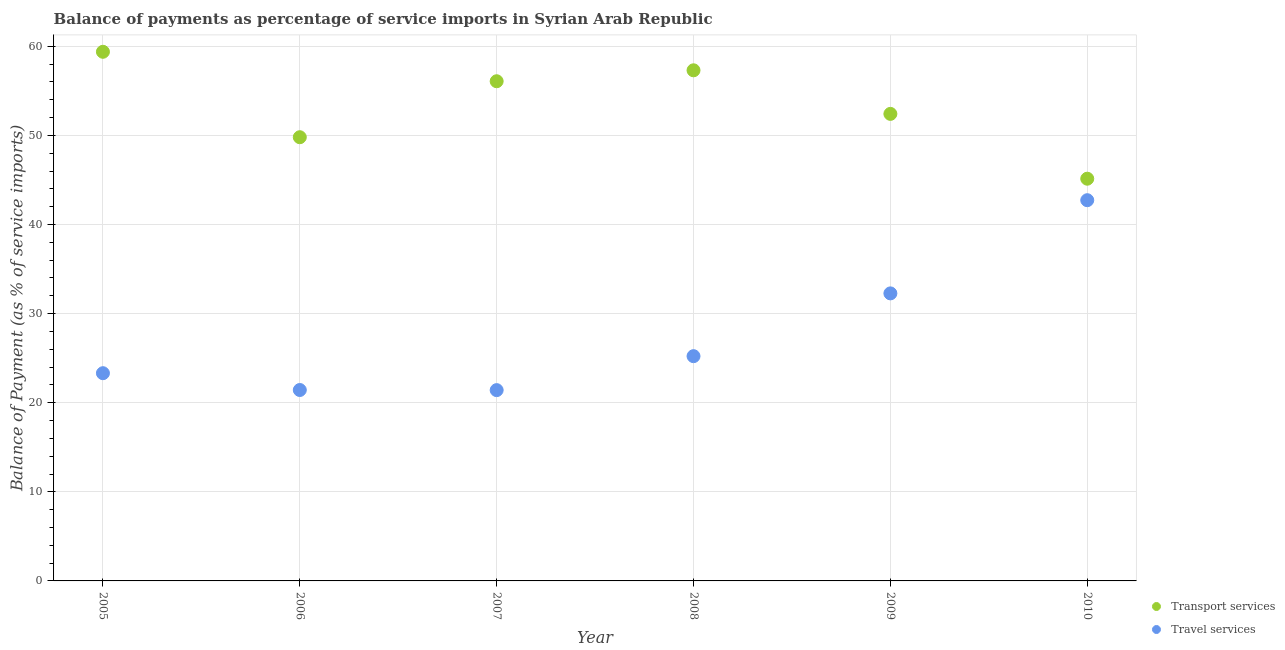Is the number of dotlines equal to the number of legend labels?
Offer a terse response. Yes. What is the balance of payments of travel services in 2010?
Make the answer very short. 42.73. Across all years, what is the maximum balance of payments of transport services?
Your answer should be compact. 59.39. Across all years, what is the minimum balance of payments of travel services?
Your response must be concise. 21.41. In which year was the balance of payments of travel services minimum?
Ensure brevity in your answer.  2007. What is the total balance of payments of transport services in the graph?
Make the answer very short. 320.15. What is the difference between the balance of payments of travel services in 2007 and that in 2008?
Your answer should be very brief. -3.81. What is the difference between the balance of payments of travel services in 2006 and the balance of payments of transport services in 2008?
Your response must be concise. -35.88. What is the average balance of payments of transport services per year?
Your answer should be compact. 53.36. In the year 2005, what is the difference between the balance of payments of transport services and balance of payments of travel services?
Your answer should be very brief. 36.07. What is the ratio of the balance of payments of transport services in 2006 to that in 2009?
Your response must be concise. 0.95. Is the balance of payments of travel services in 2007 less than that in 2009?
Your response must be concise. Yes. Is the difference between the balance of payments of transport services in 2008 and 2010 greater than the difference between the balance of payments of travel services in 2008 and 2010?
Keep it short and to the point. Yes. What is the difference between the highest and the second highest balance of payments of travel services?
Ensure brevity in your answer.  10.46. What is the difference between the highest and the lowest balance of payments of transport services?
Your answer should be compact. 14.24. Is the sum of the balance of payments of transport services in 2007 and 2010 greater than the maximum balance of payments of travel services across all years?
Give a very brief answer. Yes. Is the balance of payments of transport services strictly greater than the balance of payments of travel services over the years?
Make the answer very short. Yes. How many years are there in the graph?
Your answer should be compact. 6. What is the difference between two consecutive major ticks on the Y-axis?
Make the answer very short. 10. Are the values on the major ticks of Y-axis written in scientific E-notation?
Provide a short and direct response. No. Does the graph contain any zero values?
Your answer should be very brief. No. What is the title of the graph?
Ensure brevity in your answer.  Balance of payments as percentage of service imports in Syrian Arab Republic. What is the label or title of the X-axis?
Keep it short and to the point. Year. What is the label or title of the Y-axis?
Your answer should be compact. Balance of Payment (as % of service imports). What is the Balance of Payment (as % of service imports) in Transport services in 2005?
Your response must be concise. 59.39. What is the Balance of Payment (as % of service imports) of Travel services in 2005?
Your response must be concise. 23.31. What is the Balance of Payment (as % of service imports) in Transport services in 2006?
Your answer should be compact. 49.8. What is the Balance of Payment (as % of service imports) of Travel services in 2006?
Offer a very short reply. 21.43. What is the Balance of Payment (as % of service imports) of Transport services in 2007?
Your response must be concise. 56.08. What is the Balance of Payment (as % of service imports) of Travel services in 2007?
Your answer should be compact. 21.41. What is the Balance of Payment (as % of service imports) of Transport services in 2008?
Offer a terse response. 57.31. What is the Balance of Payment (as % of service imports) of Travel services in 2008?
Provide a succinct answer. 25.23. What is the Balance of Payment (as % of service imports) of Transport services in 2009?
Your response must be concise. 52.42. What is the Balance of Payment (as % of service imports) in Travel services in 2009?
Your answer should be very brief. 32.27. What is the Balance of Payment (as % of service imports) of Transport services in 2010?
Provide a short and direct response. 45.14. What is the Balance of Payment (as % of service imports) in Travel services in 2010?
Make the answer very short. 42.73. Across all years, what is the maximum Balance of Payment (as % of service imports) in Transport services?
Your response must be concise. 59.39. Across all years, what is the maximum Balance of Payment (as % of service imports) in Travel services?
Keep it short and to the point. 42.73. Across all years, what is the minimum Balance of Payment (as % of service imports) of Transport services?
Your answer should be very brief. 45.14. Across all years, what is the minimum Balance of Payment (as % of service imports) of Travel services?
Give a very brief answer. 21.41. What is the total Balance of Payment (as % of service imports) of Transport services in the graph?
Ensure brevity in your answer.  320.15. What is the total Balance of Payment (as % of service imports) of Travel services in the graph?
Ensure brevity in your answer.  166.39. What is the difference between the Balance of Payment (as % of service imports) of Transport services in 2005 and that in 2006?
Provide a succinct answer. 9.59. What is the difference between the Balance of Payment (as % of service imports) of Travel services in 2005 and that in 2006?
Make the answer very short. 1.89. What is the difference between the Balance of Payment (as % of service imports) of Transport services in 2005 and that in 2007?
Provide a short and direct response. 3.31. What is the difference between the Balance of Payment (as % of service imports) in Travel services in 2005 and that in 2007?
Offer a terse response. 1.9. What is the difference between the Balance of Payment (as % of service imports) in Transport services in 2005 and that in 2008?
Your response must be concise. 2.08. What is the difference between the Balance of Payment (as % of service imports) in Travel services in 2005 and that in 2008?
Offer a terse response. -1.91. What is the difference between the Balance of Payment (as % of service imports) of Transport services in 2005 and that in 2009?
Make the answer very short. 6.97. What is the difference between the Balance of Payment (as % of service imports) of Travel services in 2005 and that in 2009?
Provide a succinct answer. -8.96. What is the difference between the Balance of Payment (as % of service imports) in Transport services in 2005 and that in 2010?
Provide a succinct answer. 14.24. What is the difference between the Balance of Payment (as % of service imports) of Travel services in 2005 and that in 2010?
Offer a terse response. -19.42. What is the difference between the Balance of Payment (as % of service imports) of Transport services in 2006 and that in 2007?
Offer a terse response. -6.28. What is the difference between the Balance of Payment (as % of service imports) of Travel services in 2006 and that in 2007?
Keep it short and to the point. 0.01. What is the difference between the Balance of Payment (as % of service imports) in Transport services in 2006 and that in 2008?
Provide a succinct answer. -7.51. What is the difference between the Balance of Payment (as % of service imports) of Travel services in 2006 and that in 2008?
Offer a very short reply. -3.8. What is the difference between the Balance of Payment (as % of service imports) in Transport services in 2006 and that in 2009?
Your answer should be very brief. -2.62. What is the difference between the Balance of Payment (as % of service imports) of Travel services in 2006 and that in 2009?
Provide a short and direct response. -10.84. What is the difference between the Balance of Payment (as % of service imports) of Transport services in 2006 and that in 2010?
Your response must be concise. 4.66. What is the difference between the Balance of Payment (as % of service imports) of Travel services in 2006 and that in 2010?
Ensure brevity in your answer.  -21.3. What is the difference between the Balance of Payment (as % of service imports) in Transport services in 2007 and that in 2008?
Provide a succinct answer. -1.23. What is the difference between the Balance of Payment (as % of service imports) of Travel services in 2007 and that in 2008?
Provide a succinct answer. -3.81. What is the difference between the Balance of Payment (as % of service imports) of Transport services in 2007 and that in 2009?
Your response must be concise. 3.66. What is the difference between the Balance of Payment (as % of service imports) of Travel services in 2007 and that in 2009?
Provide a succinct answer. -10.86. What is the difference between the Balance of Payment (as % of service imports) in Transport services in 2007 and that in 2010?
Give a very brief answer. 10.94. What is the difference between the Balance of Payment (as % of service imports) of Travel services in 2007 and that in 2010?
Ensure brevity in your answer.  -21.32. What is the difference between the Balance of Payment (as % of service imports) in Transport services in 2008 and that in 2009?
Provide a succinct answer. 4.89. What is the difference between the Balance of Payment (as % of service imports) of Travel services in 2008 and that in 2009?
Make the answer very short. -7.05. What is the difference between the Balance of Payment (as % of service imports) of Transport services in 2008 and that in 2010?
Make the answer very short. 12.17. What is the difference between the Balance of Payment (as % of service imports) in Travel services in 2008 and that in 2010?
Provide a short and direct response. -17.51. What is the difference between the Balance of Payment (as % of service imports) of Transport services in 2009 and that in 2010?
Your response must be concise. 7.28. What is the difference between the Balance of Payment (as % of service imports) of Travel services in 2009 and that in 2010?
Keep it short and to the point. -10.46. What is the difference between the Balance of Payment (as % of service imports) of Transport services in 2005 and the Balance of Payment (as % of service imports) of Travel services in 2006?
Your answer should be very brief. 37.96. What is the difference between the Balance of Payment (as % of service imports) in Transport services in 2005 and the Balance of Payment (as % of service imports) in Travel services in 2007?
Ensure brevity in your answer.  37.97. What is the difference between the Balance of Payment (as % of service imports) in Transport services in 2005 and the Balance of Payment (as % of service imports) in Travel services in 2008?
Offer a terse response. 34.16. What is the difference between the Balance of Payment (as % of service imports) in Transport services in 2005 and the Balance of Payment (as % of service imports) in Travel services in 2009?
Your answer should be compact. 27.12. What is the difference between the Balance of Payment (as % of service imports) of Transport services in 2005 and the Balance of Payment (as % of service imports) of Travel services in 2010?
Your answer should be compact. 16.66. What is the difference between the Balance of Payment (as % of service imports) of Transport services in 2006 and the Balance of Payment (as % of service imports) of Travel services in 2007?
Ensure brevity in your answer.  28.39. What is the difference between the Balance of Payment (as % of service imports) of Transport services in 2006 and the Balance of Payment (as % of service imports) of Travel services in 2008?
Ensure brevity in your answer.  24.57. What is the difference between the Balance of Payment (as % of service imports) in Transport services in 2006 and the Balance of Payment (as % of service imports) in Travel services in 2009?
Keep it short and to the point. 17.53. What is the difference between the Balance of Payment (as % of service imports) in Transport services in 2006 and the Balance of Payment (as % of service imports) in Travel services in 2010?
Provide a short and direct response. 7.07. What is the difference between the Balance of Payment (as % of service imports) in Transport services in 2007 and the Balance of Payment (as % of service imports) in Travel services in 2008?
Your response must be concise. 30.86. What is the difference between the Balance of Payment (as % of service imports) in Transport services in 2007 and the Balance of Payment (as % of service imports) in Travel services in 2009?
Ensure brevity in your answer.  23.81. What is the difference between the Balance of Payment (as % of service imports) in Transport services in 2007 and the Balance of Payment (as % of service imports) in Travel services in 2010?
Give a very brief answer. 13.35. What is the difference between the Balance of Payment (as % of service imports) of Transport services in 2008 and the Balance of Payment (as % of service imports) of Travel services in 2009?
Make the answer very short. 25.04. What is the difference between the Balance of Payment (as % of service imports) of Transport services in 2008 and the Balance of Payment (as % of service imports) of Travel services in 2010?
Your answer should be very brief. 14.58. What is the difference between the Balance of Payment (as % of service imports) of Transport services in 2009 and the Balance of Payment (as % of service imports) of Travel services in 2010?
Provide a short and direct response. 9.69. What is the average Balance of Payment (as % of service imports) in Transport services per year?
Provide a short and direct response. 53.36. What is the average Balance of Payment (as % of service imports) in Travel services per year?
Provide a succinct answer. 27.73. In the year 2005, what is the difference between the Balance of Payment (as % of service imports) in Transport services and Balance of Payment (as % of service imports) in Travel services?
Provide a short and direct response. 36.07. In the year 2006, what is the difference between the Balance of Payment (as % of service imports) of Transport services and Balance of Payment (as % of service imports) of Travel services?
Offer a very short reply. 28.37. In the year 2007, what is the difference between the Balance of Payment (as % of service imports) in Transport services and Balance of Payment (as % of service imports) in Travel services?
Keep it short and to the point. 34.67. In the year 2008, what is the difference between the Balance of Payment (as % of service imports) in Transport services and Balance of Payment (as % of service imports) in Travel services?
Offer a terse response. 32.09. In the year 2009, what is the difference between the Balance of Payment (as % of service imports) in Transport services and Balance of Payment (as % of service imports) in Travel services?
Your answer should be very brief. 20.15. In the year 2010, what is the difference between the Balance of Payment (as % of service imports) in Transport services and Balance of Payment (as % of service imports) in Travel services?
Provide a succinct answer. 2.41. What is the ratio of the Balance of Payment (as % of service imports) of Transport services in 2005 to that in 2006?
Offer a very short reply. 1.19. What is the ratio of the Balance of Payment (as % of service imports) of Travel services in 2005 to that in 2006?
Offer a very short reply. 1.09. What is the ratio of the Balance of Payment (as % of service imports) in Transport services in 2005 to that in 2007?
Provide a short and direct response. 1.06. What is the ratio of the Balance of Payment (as % of service imports) in Travel services in 2005 to that in 2007?
Provide a short and direct response. 1.09. What is the ratio of the Balance of Payment (as % of service imports) in Transport services in 2005 to that in 2008?
Your answer should be compact. 1.04. What is the ratio of the Balance of Payment (as % of service imports) of Travel services in 2005 to that in 2008?
Make the answer very short. 0.92. What is the ratio of the Balance of Payment (as % of service imports) in Transport services in 2005 to that in 2009?
Offer a very short reply. 1.13. What is the ratio of the Balance of Payment (as % of service imports) in Travel services in 2005 to that in 2009?
Your response must be concise. 0.72. What is the ratio of the Balance of Payment (as % of service imports) in Transport services in 2005 to that in 2010?
Keep it short and to the point. 1.32. What is the ratio of the Balance of Payment (as % of service imports) in Travel services in 2005 to that in 2010?
Your answer should be very brief. 0.55. What is the ratio of the Balance of Payment (as % of service imports) of Transport services in 2006 to that in 2007?
Your response must be concise. 0.89. What is the ratio of the Balance of Payment (as % of service imports) of Travel services in 2006 to that in 2007?
Give a very brief answer. 1. What is the ratio of the Balance of Payment (as % of service imports) of Transport services in 2006 to that in 2008?
Your response must be concise. 0.87. What is the ratio of the Balance of Payment (as % of service imports) of Travel services in 2006 to that in 2008?
Offer a very short reply. 0.85. What is the ratio of the Balance of Payment (as % of service imports) in Travel services in 2006 to that in 2009?
Your answer should be very brief. 0.66. What is the ratio of the Balance of Payment (as % of service imports) of Transport services in 2006 to that in 2010?
Make the answer very short. 1.1. What is the ratio of the Balance of Payment (as % of service imports) in Travel services in 2006 to that in 2010?
Offer a very short reply. 0.5. What is the ratio of the Balance of Payment (as % of service imports) of Transport services in 2007 to that in 2008?
Your answer should be very brief. 0.98. What is the ratio of the Balance of Payment (as % of service imports) in Travel services in 2007 to that in 2008?
Your response must be concise. 0.85. What is the ratio of the Balance of Payment (as % of service imports) in Transport services in 2007 to that in 2009?
Provide a short and direct response. 1.07. What is the ratio of the Balance of Payment (as % of service imports) of Travel services in 2007 to that in 2009?
Ensure brevity in your answer.  0.66. What is the ratio of the Balance of Payment (as % of service imports) in Transport services in 2007 to that in 2010?
Your response must be concise. 1.24. What is the ratio of the Balance of Payment (as % of service imports) in Travel services in 2007 to that in 2010?
Ensure brevity in your answer.  0.5. What is the ratio of the Balance of Payment (as % of service imports) of Transport services in 2008 to that in 2009?
Ensure brevity in your answer.  1.09. What is the ratio of the Balance of Payment (as % of service imports) of Travel services in 2008 to that in 2009?
Offer a terse response. 0.78. What is the ratio of the Balance of Payment (as % of service imports) in Transport services in 2008 to that in 2010?
Your response must be concise. 1.27. What is the ratio of the Balance of Payment (as % of service imports) in Travel services in 2008 to that in 2010?
Offer a terse response. 0.59. What is the ratio of the Balance of Payment (as % of service imports) of Transport services in 2009 to that in 2010?
Make the answer very short. 1.16. What is the ratio of the Balance of Payment (as % of service imports) of Travel services in 2009 to that in 2010?
Keep it short and to the point. 0.76. What is the difference between the highest and the second highest Balance of Payment (as % of service imports) in Transport services?
Provide a short and direct response. 2.08. What is the difference between the highest and the second highest Balance of Payment (as % of service imports) in Travel services?
Provide a short and direct response. 10.46. What is the difference between the highest and the lowest Balance of Payment (as % of service imports) of Transport services?
Provide a succinct answer. 14.24. What is the difference between the highest and the lowest Balance of Payment (as % of service imports) of Travel services?
Ensure brevity in your answer.  21.32. 